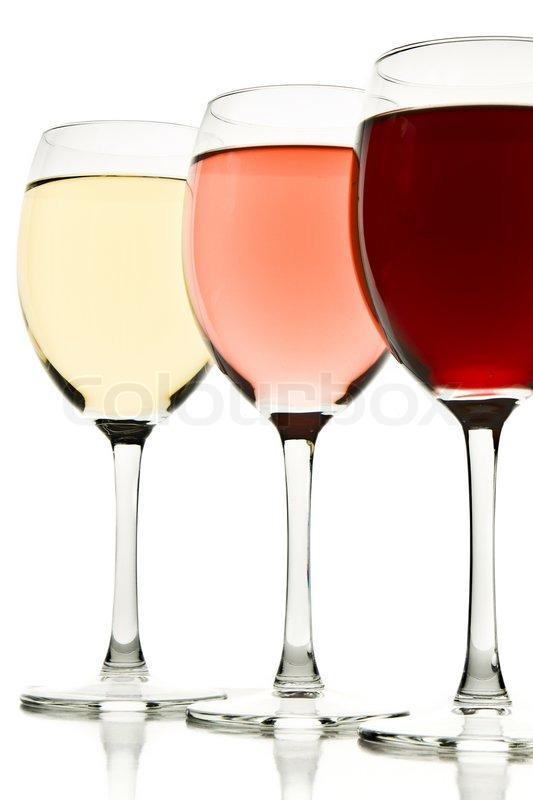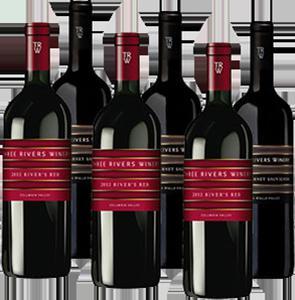The first image is the image on the left, the second image is the image on the right. Examine the images to the left and right. Is the description "Three wine glasses are lined up in the image on the left." accurate? Answer yes or no. Yes. The first image is the image on the left, the second image is the image on the right. Evaluate the accuracy of this statement regarding the images: "An image includes at least one bottle with a burgundy colored label and wrap over the cap.". Is it true? Answer yes or no. Yes. 